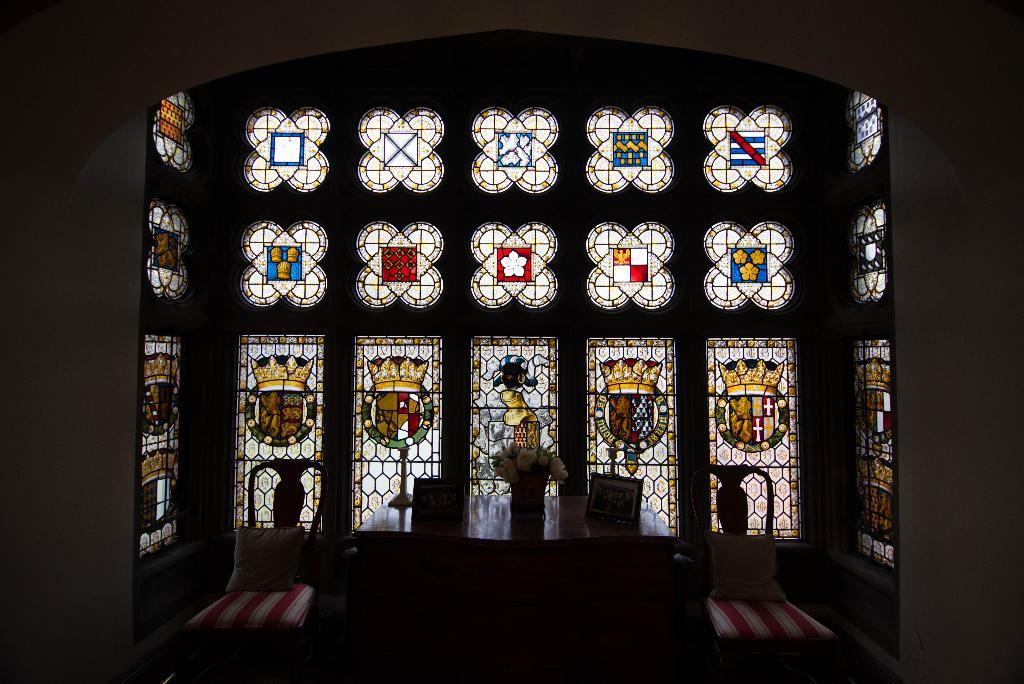What is the main feature in the center of the image? There is a glass window in the center of the image. What is located at the bottom side of the image? There is a table at the bottom side of the image. What can be found on the table in the image? There is a flower vase on the table. What type of insect can be seen painting on the glass window in the image? There is no insect or painting present on the glass window in the image. What type of plough is used to cultivate the table in the image? There is no plough present in the image, and the table is not a field to be cultivated. 